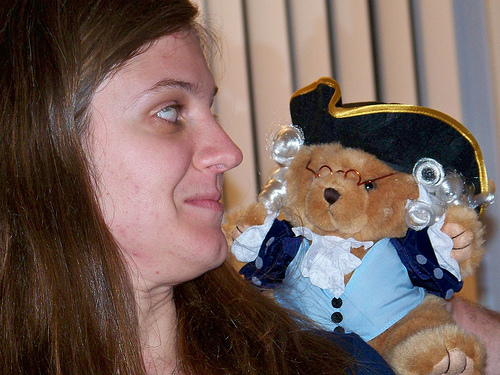<image>
Is there a woman behind the teddy bear? No. The woman is not behind the teddy bear. From this viewpoint, the woman appears to be positioned elsewhere in the scene. Is there a woman behind the stuffed bear? No. The woman is not behind the stuffed bear. From this viewpoint, the woman appears to be positioned elsewhere in the scene. 